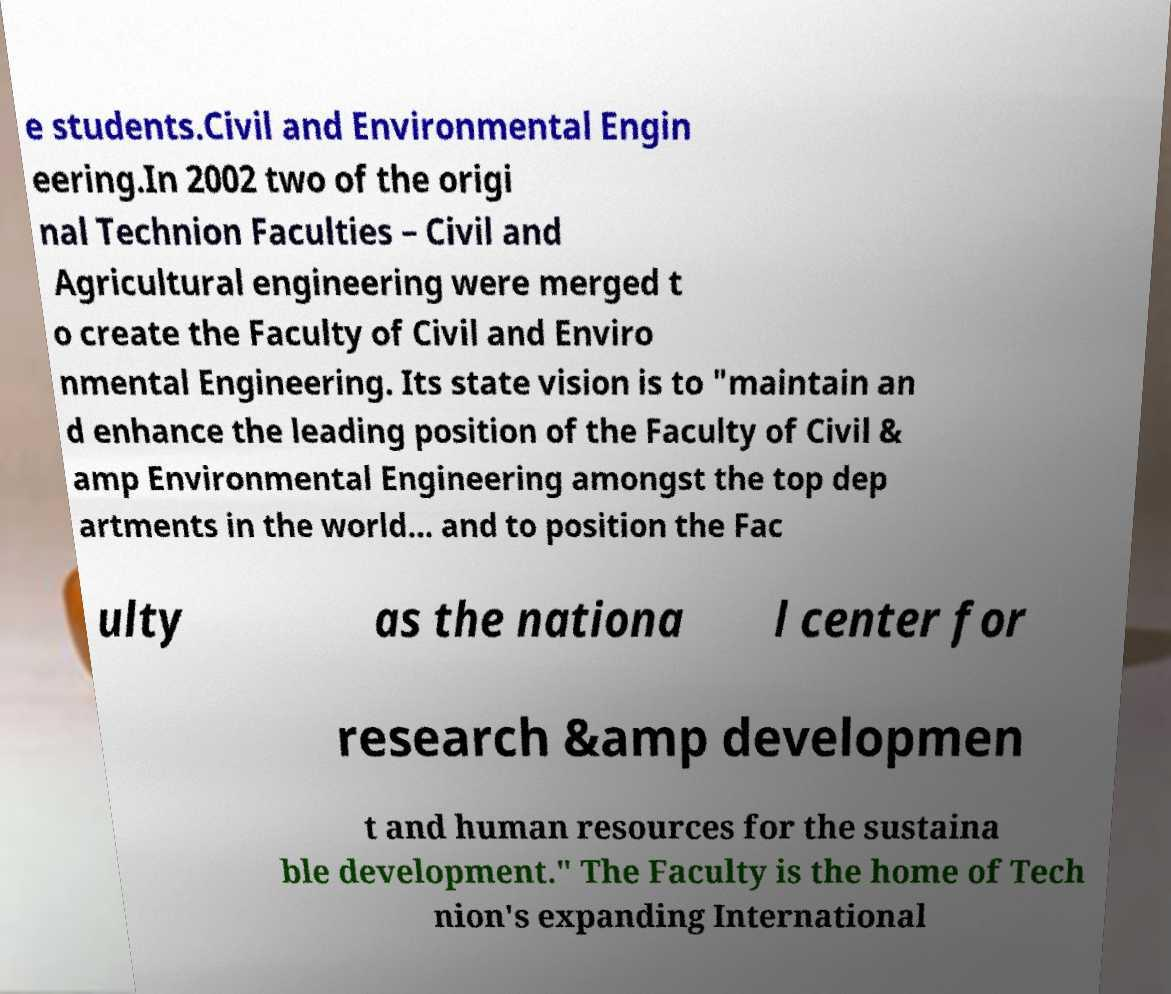Can you read and provide the text displayed in the image?This photo seems to have some interesting text. Can you extract and type it out for me? e students.Civil and Environmental Engin eering.In 2002 two of the origi nal Technion Faculties – Civil and Agricultural engineering were merged t o create the Faculty of Civil and Enviro nmental Engineering. Its state vision is to "maintain an d enhance the leading position of the Faculty of Civil & amp Environmental Engineering amongst the top dep artments in the world... and to position the Fac ulty as the nationa l center for research &amp developmen t and human resources for the sustaina ble development." The Faculty is the home of Tech nion's expanding International 